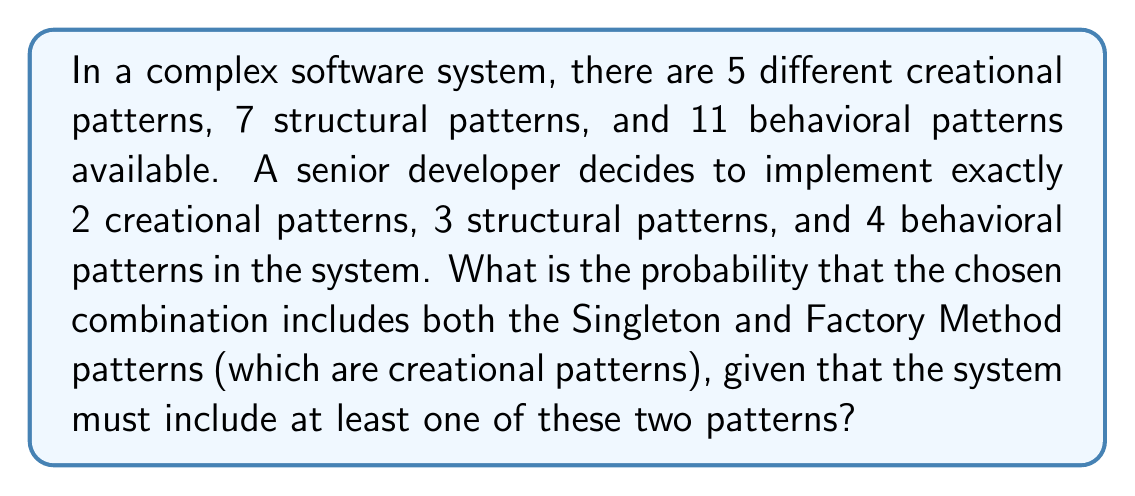Can you answer this question? Let's approach this step-by-step:

1) First, we need to calculate the total number of possible combinations:
   - Choosing 2 out of 5 creational patterns: $\binom{5}{2}$
   - Choosing 3 out of 7 structural patterns: $\binom{7}{3}$
   - Choosing 4 out of 11 behavioral patterns: $\binom{11}{4}$

   Total combinations = $\binom{5}{2} \cdot \binom{7}{3} \cdot \binom{11}{4}$

2) Now, let's consider the favorable outcomes. We need to include both Singleton and Factory Method, plus any other creational patterns. There are three cases:
   a) Both Singleton and Factory Method, no other creational pattern
   b) Both Singleton and Factory Method, plus one other creational pattern

3) For case (a):
   - Choosing 2 specific creational patterns: 1 way
   - Choosing 3 out of 7 structural patterns: $\binom{7}{3}$
   - Choosing 4 out of 11 behavioral patterns: $\binom{11}{4}$

4) For case (b):
   - Choosing 1 out of the remaining 3 creational patterns: $\binom{3}{1}$
   - Choosing 3 out of 7 structural patterns: $\binom{7}{3}$
   - Choosing 4 out of 11 behavioral patterns: $\binom{11}{4}$

5) Total favorable outcomes = Case (a) + Case (b)
   $= (1 \cdot \binom{7}{3} \cdot \binom{11}{4}) + (\binom{3}{1} \cdot \binom{7}{3} \cdot \binom{11}{4})$
   $= (1 + 3) \cdot \binom{7}{3} \cdot \binom{11}{4}$
   $= 4 \cdot \binom{7}{3} \cdot \binom{11}{4}$

6) Probability = $\frac{\text{Favorable outcomes}}{\text{Total outcomes}}$
   $$P = \frac{4 \cdot \binom{7}{3} \cdot \binom{11}{4}}{\binom{5}{2} \cdot \binom{7}{3} \cdot \binom{11}{4}}$$

7) Simplify:
   $$P = \frac{4}{\binom{5}{2}} = \frac{4}{10} = \frac{2}{5} = 0.4$$
Answer: The probability is $\frac{2}{5}$ or 0.4 or 40%. 